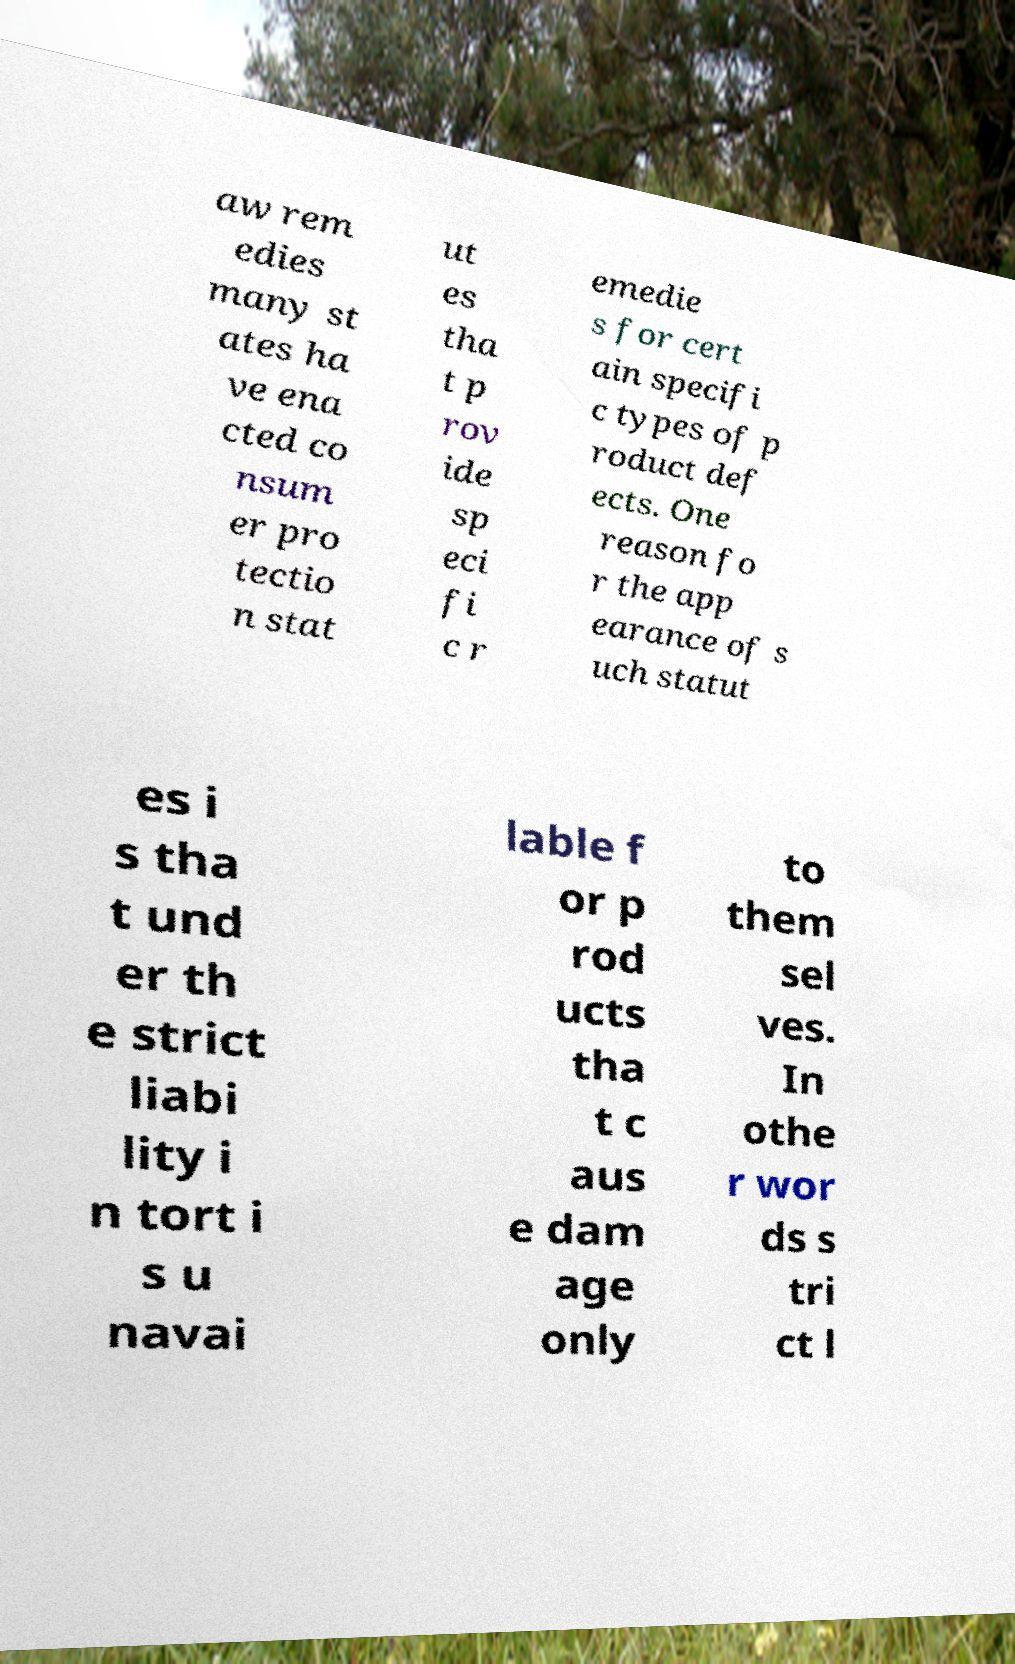I need the written content from this picture converted into text. Can you do that? aw rem edies many st ates ha ve ena cted co nsum er pro tectio n stat ut es tha t p rov ide sp eci fi c r emedie s for cert ain specifi c types of p roduct def ects. One reason fo r the app earance of s uch statut es i s tha t und er th e strict liabi lity i n tort i s u navai lable f or p rod ucts tha t c aus e dam age only to them sel ves. In othe r wor ds s tri ct l 